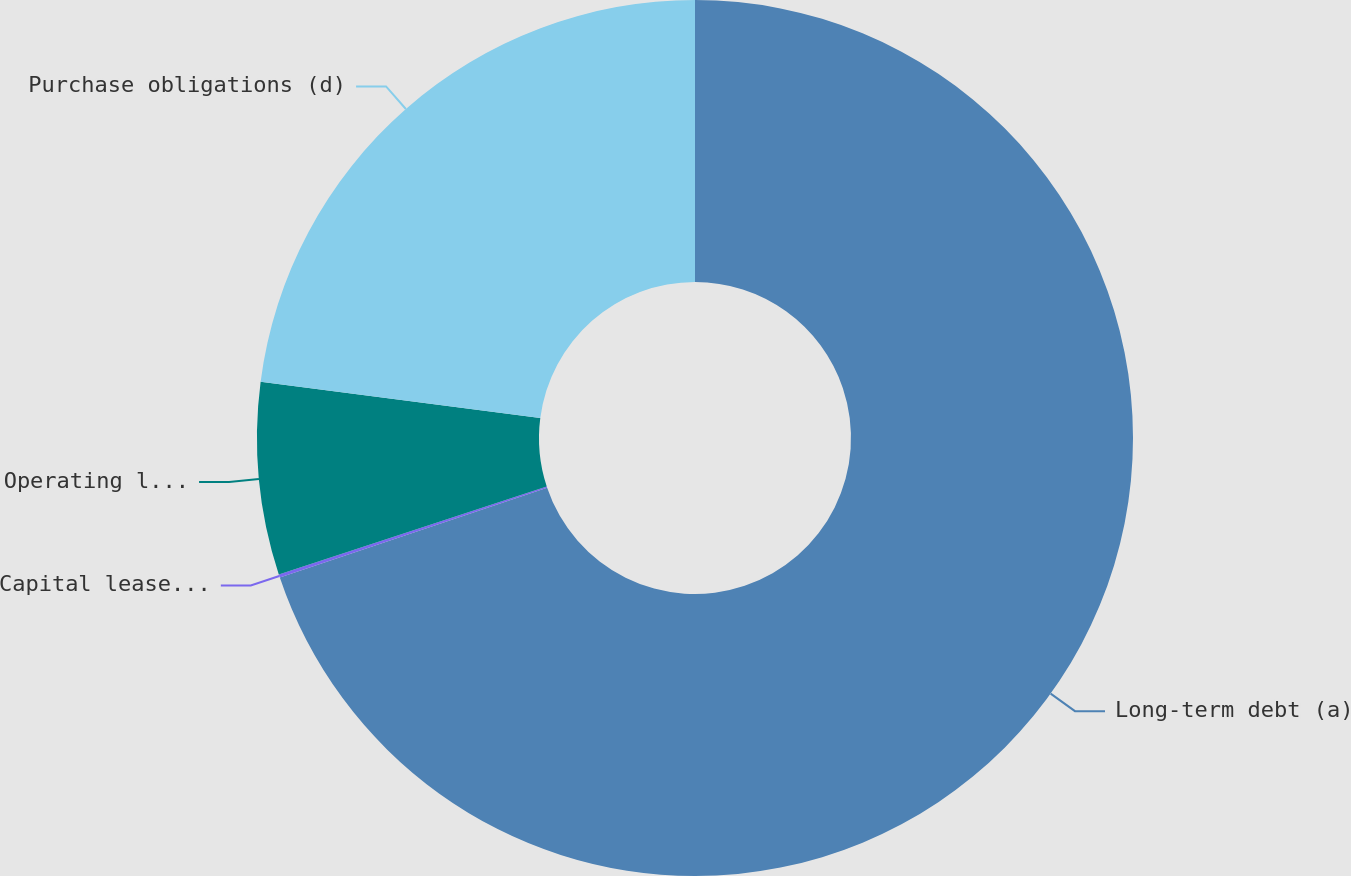<chart> <loc_0><loc_0><loc_500><loc_500><pie_chart><fcel>Long-term debt (a)<fcel>Capital lease payments (b)<fcel>Operating leases (b) (c)<fcel>Purchase obligations (d)<nl><fcel>69.84%<fcel>0.12%<fcel>7.09%<fcel>22.95%<nl></chart> 